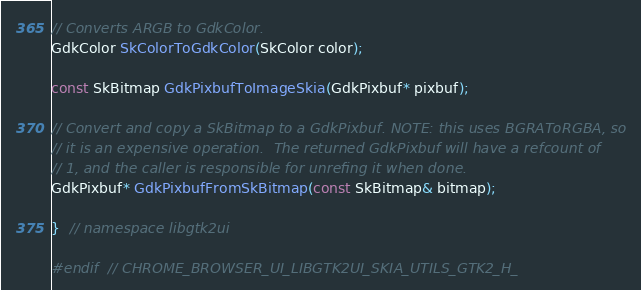Convert code to text. <code><loc_0><loc_0><loc_500><loc_500><_C_>// Converts ARGB to GdkColor.
GdkColor SkColorToGdkColor(SkColor color);

const SkBitmap GdkPixbufToImageSkia(GdkPixbuf* pixbuf);

// Convert and copy a SkBitmap to a GdkPixbuf. NOTE: this uses BGRAToRGBA, so
// it is an expensive operation.  The returned GdkPixbuf will have a refcount of
// 1, and the caller is responsible for unrefing it when done.
GdkPixbuf* GdkPixbufFromSkBitmap(const SkBitmap& bitmap);

}  // namespace libgtk2ui

#endif  // CHROME_BROWSER_UI_LIBGTK2UI_SKIA_UTILS_GTK2_H_
</code> 